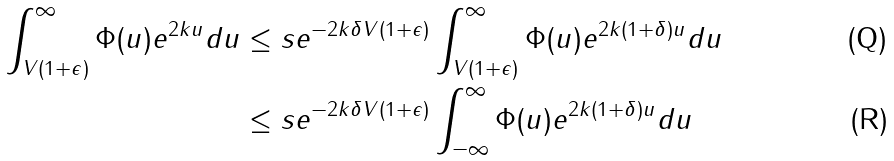Convert formula to latex. <formula><loc_0><loc_0><loc_500><loc_500>\int _ { V ( 1 + \epsilon ) } ^ { \infty } \Phi ( u ) e ^ { 2 k u } d u \leq s & e ^ { - 2 k \delta V ( 1 + \epsilon ) } \int _ { V ( 1 + \epsilon ) } ^ { \infty } \Phi ( u ) e ^ { 2 k ( 1 + \delta ) u } d u \\ \leq s & e ^ { - 2 k \delta V ( 1 + \epsilon ) } \int _ { - \infty } ^ { \infty } \Phi ( u ) e ^ { 2 k ( 1 + \delta ) u } d u</formula> 